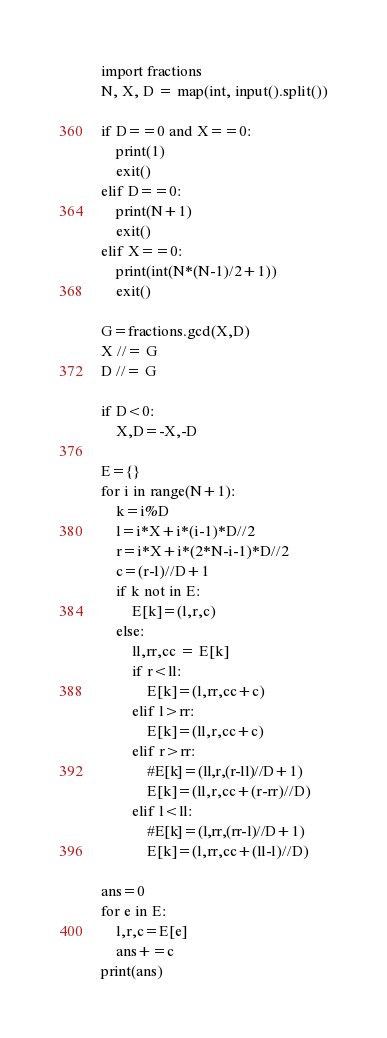Convert code to text. <code><loc_0><loc_0><loc_500><loc_500><_Python_>import fractions
N, X, D = map(int, input().split())

if D==0 and X==0:
    print(1)
    exit()
elif D==0:
    print(N+1)
    exit()
elif X==0:
    print(int(N*(N-1)/2+1))
    exit()

G=fractions.gcd(X,D)
X //= G
D //= G

if D<0:
    X,D=-X,-D

E={} 
for i in range(N+1):
    k=i%D
    l=i*X+i*(i-1)*D//2
    r=i*X+i*(2*N-i-1)*D//2
    c=(r-l)//D+1
    if k not in E:
        E[k]=(l,r,c)
    else:
        ll,rr,cc = E[k]
        if r<ll:
            E[k]=(l,rr,cc+c)
        elif l>rr:
            E[k]=(ll,r,cc+c)
        elif r>rr:
            #E[k]=(ll,r,(r-ll)//D+1)
            E[k]=(ll,r,cc+(r-rr)//D)
        elif l<ll:
            #E[k]=(l,rr,(rr-l)//D+1)
            E[k]=(l,rr,cc+(ll-l)//D)

ans=0
for e in E:
    l,r,c=E[e]
    ans+=c
print(ans)
</code> 